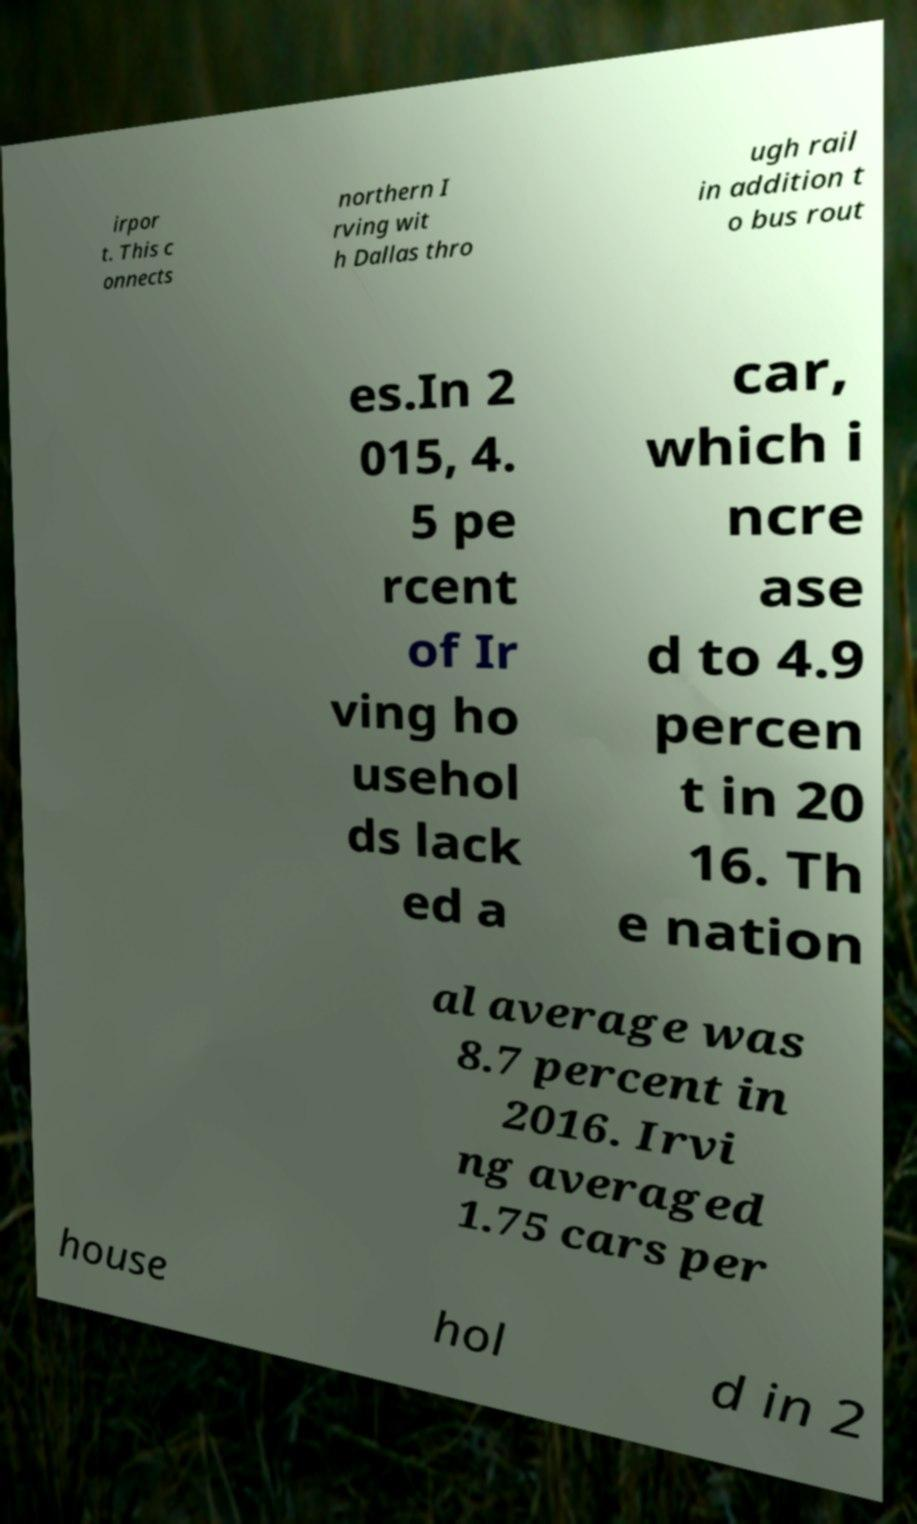Please read and relay the text visible in this image. What does it say? irpor t. This c onnects northern I rving wit h Dallas thro ugh rail in addition t o bus rout es.In 2 015, 4. 5 pe rcent of Ir ving ho usehol ds lack ed a car, which i ncre ase d to 4.9 percen t in 20 16. Th e nation al average was 8.7 percent in 2016. Irvi ng averaged 1.75 cars per house hol d in 2 